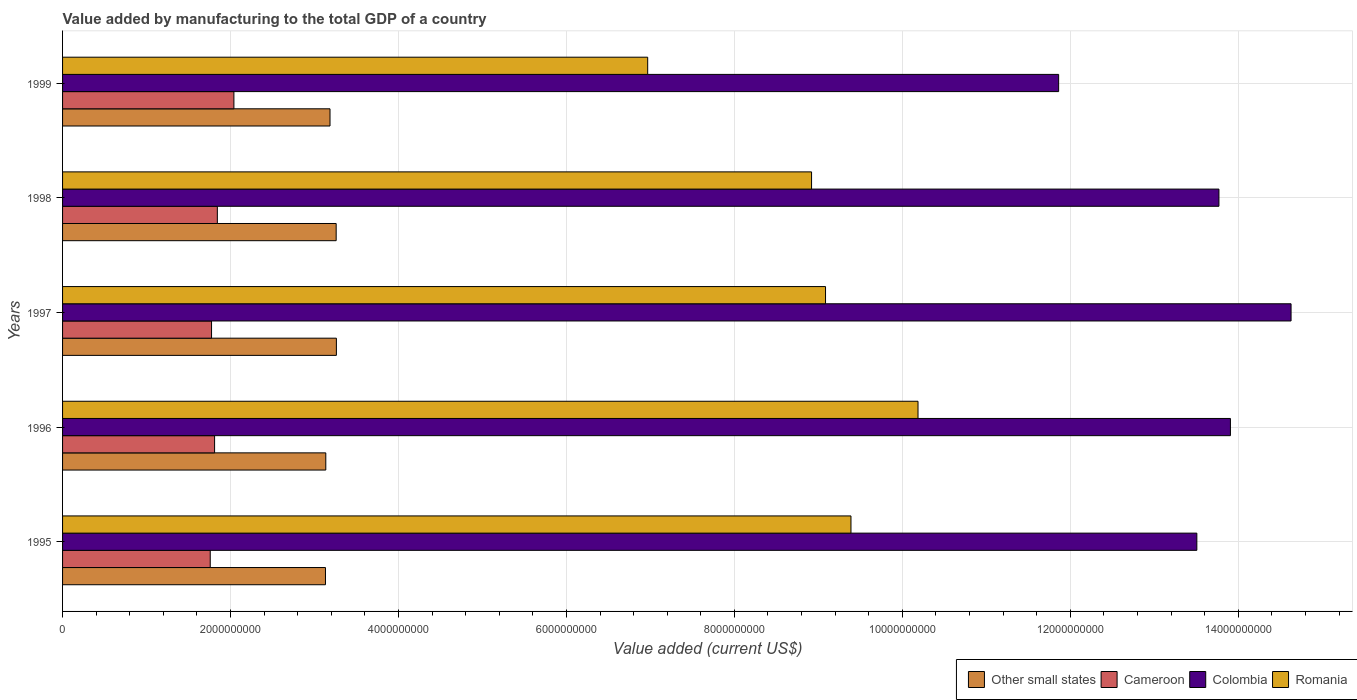How many groups of bars are there?
Your answer should be very brief. 5. How many bars are there on the 2nd tick from the bottom?
Your answer should be very brief. 4. What is the label of the 4th group of bars from the top?
Give a very brief answer. 1996. In how many cases, is the number of bars for a given year not equal to the number of legend labels?
Your response must be concise. 0. What is the value added by manufacturing to the total GDP in Romania in 1996?
Provide a short and direct response. 1.02e+1. Across all years, what is the maximum value added by manufacturing to the total GDP in Romania?
Provide a succinct answer. 1.02e+1. Across all years, what is the minimum value added by manufacturing to the total GDP in Colombia?
Provide a succinct answer. 1.19e+1. In which year was the value added by manufacturing to the total GDP in Colombia maximum?
Your answer should be compact. 1997. What is the total value added by manufacturing to the total GDP in Colombia in the graph?
Give a very brief answer. 6.77e+1. What is the difference between the value added by manufacturing to the total GDP in Other small states in 1995 and that in 1999?
Provide a succinct answer. -5.41e+07. What is the difference between the value added by manufacturing to the total GDP in Cameroon in 1996 and the value added by manufacturing to the total GDP in Other small states in 1995?
Your answer should be very brief. -1.32e+09. What is the average value added by manufacturing to the total GDP in Cameroon per year?
Make the answer very short. 1.85e+09. In the year 1996, what is the difference between the value added by manufacturing to the total GDP in Cameroon and value added by manufacturing to the total GDP in Colombia?
Your answer should be very brief. -1.21e+1. What is the ratio of the value added by manufacturing to the total GDP in Other small states in 1995 to that in 1999?
Keep it short and to the point. 0.98. Is the value added by manufacturing to the total GDP in Colombia in 1995 less than that in 1997?
Your answer should be very brief. Yes. What is the difference between the highest and the second highest value added by manufacturing to the total GDP in Cameroon?
Offer a terse response. 1.97e+08. What is the difference between the highest and the lowest value added by manufacturing to the total GDP in Cameroon?
Offer a terse response. 2.82e+08. In how many years, is the value added by manufacturing to the total GDP in Other small states greater than the average value added by manufacturing to the total GDP in Other small states taken over all years?
Offer a terse response. 2. Is it the case that in every year, the sum of the value added by manufacturing to the total GDP in Colombia and value added by manufacturing to the total GDP in Cameroon is greater than the sum of value added by manufacturing to the total GDP in Other small states and value added by manufacturing to the total GDP in Romania?
Your answer should be very brief. No. What does the 3rd bar from the top in 1999 represents?
Keep it short and to the point. Cameroon. What does the 4th bar from the bottom in 1996 represents?
Offer a very short reply. Romania. Is it the case that in every year, the sum of the value added by manufacturing to the total GDP in Cameroon and value added by manufacturing to the total GDP in Other small states is greater than the value added by manufacturing to the total GDP in Colombia?
Offer a terse response. No. How many bars are there?
Your answer should be very brief. 20. How many years are there in the graph?
Give a very brief answer. 5. What is the difference between two consecutive major ticks on the X-axis?
Make the answer very short. 2.00e+09. Are the values on the major ticks of X-axis written in scientific E-notation?
Ensure brevity in your answer.  No. Where does the legend appear in the graph?
Ensure brevity in your answer.  Bottom right. How many legend labels are there?
Your answer should be compact. 4. What is the title of the graph?
Your answer should be compact. Value added by manufacturing to the total GDP of a country. Does "St. Kitts and Nevis" appear as one of the legend labels in the graph?
Offer a very short reply. No. What is the label or title of the X-axis?
Keep it short and to the point. Value added (current US$). What is the Value added (current US$) of Other small states in 1995?
Make the answer very short. 3.13e+09. What is the Value added (current US$) of Cameroon in 1995?
Your response must be concise. 1.76e+09. What is the Value added (current US$) in Colombia in 1995?
Ensure brevity in your answer.  1.35e+1. What is the Value added (current US$) in Romania in 1995?
Your answer should be compact. 9.39e+09. What is the Value added (current US$) of Other small states in 1996?
Your response must be concise. 3.13e+09. What is the Value added (current US$) in Cameroon in 1996?
Give a very brief answer. 1.81e+09. What is the Value added (current US$) of Colombia in 1996?
Your answer should be compact. 1.39e+1. What is the Value added (current US$) in Romania in 1996?
Offer a terse response. 1.02e+1. What is the Value added (current US$) in Other small states in 1997?
Keep it short and to the point. 3.26e+09. What is the Value added (current US$) of Cameroon in 1997?
Offer a very short reply. 1.77e+09. What is the Value added (current US$) of Colombia in 1997?
Your answer should be very brief. 1.46e+1. What is the Value added (current US$) in Romania in 1997?
Provide a succinct answer. 9.09e+09. What is the Value added (current US$) of Other small states in 1998?
Give a very brief answer. 3.26e+09. What is the Value added (current US$) in Cameroon in 1998?
Ensure brevity in your answer.  1.84e+09. What is the Value added (current US$) of Colombia in 1998?
Give a very brief answer. 1.38e+1. What is the Value added (current US$) in Romania in 1998?
Offer a very short reply. 8.92e+09. What is the Value added (current US$) of Other small states in 1999?
Provide a succinct answer. 3.18e+09. What is the Value added (current US$) in Cameroon in 1999?
Ensure brevity in your answer.  2.04e+09. What is the Value added (current US$) of Colombia in 1999?
Provide a short and direct response. 1.19e+1. What is the Value added (current US$) in Romania in 1999?
Your response must be concise. 6.97e+09. Across all years, what is the maximum Value added (current US$) in Other small states?
Provide a short and direct response. 3.26e+09. Across all years, what is the maximum Value added (current US$) in Cameroon?
Keep it short and to the point. 2.04e+09. Across all years, what is the maximum Value added (current US$) of Colombia?
Make the answer very short. 1.46e+1. Across all years, what is the maximum Value added (current US$) of Romania?
Give a very brief answer. 1.02e+1. Across all years, what is the minimum Value added (current US$) in Other small states?
Give a very brief answer. 3.13e+09. Across all years, what is the minimum Value added (current US$) of Cameroon?
Offer a very short reply. 1.76e+09. Across all years, what is the minimum Value added (current US$) in Colombia?
Your answer should be compact. 1.19e+1. Across all years, what is the minimum Value added (current US$) of Romania?
Offer a terse response. 6.97e+09. What is the total Value added (current US$) in Other small states in the graph?
Offer a very short reply. 1.60e+1. What is the total Value added (current US$) in Cameroon in the graph?
Give a very brief answer. 9.23e+09. What is the total Value added (current US$) of Colombia in the graph?
Give a very brief answer. 6.77e+1. What is the total Value added (current US$) in Romania in the graph?
Ensure brevity in your answer.  4.45e+1. What is the difference between the Value added (current US$) of Other small states in 1995 and that in 1996?
Keep it short and to the point. -3.87e+06. What is the difference between the Value added (current US$) of Cameroon in 1995 and that in 1996?
Offer a terse response. -5.19e+07. What is the difference between the Value added (current US$) of Colombia in 1995 and that in 1996?
Your answer should be compact. -4.00e+08. What is the difference between the Value added (current US$) of Romania in 1995 and that in 1996?
Offer a terse response. -7.98e+08. What is the difference between the Value added (current US$) in Other small states in 1995 and that in 1997?
Offer a very short reply. -1.30e+08. What is the difference between the Value added (current US$) in Cameroon in 1995 and that in 1997?
Keep it short and to the point. -1.56e+07. What is the difference between the Value added (current US$) in Colombia in 1995 and that in 1997?
Ensure brevity in your answer.  -1.12e+09. What is the difference between the Value added (current US$) of Romania in 1995 and that in 1997?
Make the answer very short. 3.03e+08. What is the difference between the Value added (current US$) of Other small states in 1995 and that in 1998?
Offer a terse response. -1.27e+08. What is the difference between the Value added (current US$) of Cameroon in 1995 and that in 1998?
Your answer should be very brief. -8.46e+07. What is the difference between the Value added (current US$) in Colombia in 1995 and that in 1998?
Make the answer very short. -2.63e+08. What is the difference between the Value added (current US$) of Romania in 1995 and that in 1998?
Give a very brief answer. 4.69e+08. What is the difference between the Value added (current US$) in Other small states in 1995 and that in 1999?
Offer a very short reply. -5.41e+07. What is the difference between the Value added (current US$) in Cameroon in 1995 and that in 1999?
Offer a terse response. -2.82e+08. What is the difference between the Value added (current US$) in Colombia in 1995 and that in 1999?
Give a very brief answer. 1.65e+09. What is the difference between the Value added (current US$) of Romania in 1995 and that in 1999?
Provide a short and direct response. 2.42e+09. What is the difference between the Value added (current US$) of Other small states in 1996 and that in 1997?
Keep it short and to the point. -1.26e+08. What is the difference between the Value added (current US$) in Cameroon in 1996 and that in 1997?
Keep it short and to the point. 3.63e+07. What is the difference between the Value added (current US$) of Colombia in 1996 and that in 1997?
Offer a terse response. -7.22e+08. What is the difference between the Value added (current US$) in Romania in 1996 and that in 1997?
Keep it short and to the point. 1.10e+09. What is the difference between the Value added (current US$) of Other small states in 1996 and that in 1998?
Your response must be concise. -1.24e+08. What is the difference between the Value added (current US$) of Cameroon in 1996 and that in 1998?
Keep it short and to the point. -3.27e+07. What is the difference between the Value added (current US$) in Colombia in 1996 and that in 1998?
Make the answer very short. 1.37e+08. What is the difference between the Value added (current US$) in Romania in 1996 and that in 1998?
Make the answer very short. 1.27e+09. What is the difference between the Value added (current US$) of Other small states in 1996 and that in 1999?
Provide a short and direct response. -5.02e+07. What is the difference between the Value added (current US$) in Cameroon in 1996 and that in 1999?
Your answer should be very brief. -2.30e+08. What is the difference between the Value added (current US$) in Colombia in 1996 and that in 1999?
Your answer should be compact. 2.05e+09. What is the difference between the Value added (current US$) in Romania in 1996 and that in 1999?
Your answer should be very brief. 3.22e+09. What is the difference between the Value added (current US$) of Other small states in 1997 and that in 1998?
Make the answer very short. 2.66e+06. What is the difference between the Value added (current US$) of Cameroon in 1997 and that in 1998?
Offer a terse response. -6.90e+07. What is the difference between the Value added (current US$) of Colombia in 1997 and that in 1998?
Give a very brief answer. 8.59e+08. What is the difference between the Value added (current US$) of Romania in 1997 and that in 1998?
Keep it short and to the point. 1.66e+08. What is the difference between the Value added (current US$) of Other small states in 1997 and that in 1999?
Make the answer very short. 7.60e+07. What is the difference between the Value added (current US$) in Cameroon in 1997 and that in 1999?
Give a very brief answer. -2.66e+08. What is the difference between the Value added (current US$) in Colombia in 1997 and that in 1999?
Make the answer very short. 2.77e+09. What is the difference between the Value added (current US$) in Romania in 1997 and that in 1999?
Your answer should be very brief. 2.12e+09. What is the difference between the Value added (current US$) in Other small states in 1998 and that in 1999?
Offer a terse response. 7.34e+07. What is the difference between the Value added (current US$) of Cameroon in 1998 and that in 1999?
Keep it short and to the point. -1.97e+08. What is the difference between the Value added (current US$) in Colombia in 1998 and that in 1999?
Provide a succinct answer. 1.91e+09. What is the difference between the Value added (current US$) in Romania in 1998 and that in 1999?
Provide a succinct answer. 1.95e+09. What is the difference between the Value added (current US$) in Other small states in 1995 and the Value added (current US$) in Cameroon in 1996?
Offer a very short reply. 1.32e+09. What is the difference between the Value added (current US$) in Other small states in 1995 and the Value added (current US$) in Colombia in 1996?
Ensure brevity in your answer.  -1.08e+1. What is the difference between the Value added (current US$) in Other small states in 1995 and the Value added (current US$) in Romania in 1996?
Your response must be concise. -7.06e+09. What is the difference between the Value added (current US$) in Cameroon in 1995 and the Value added (current US$) in Colombia in 1996?
Your response must be concise. -1.21e+1. What is the difference between the Value added (current US$) of Cameroon in 1995 and the Value added (current US$) of Romania in 1996?
Your response must be concise. -8.43e+09. What is the difference between the Value added (current US$) in Colombia in 1995 and the Value added (current US$) in Romania in 1996?
Give a very brief answer. 3.32e+09. What is the difference between the Value added (current US$) of Other small states in 1995 and the Value added (current US$) of Cameroon in 1997?
Your answer should be very brief. 1.36e+09. What is the difference between the Value added (current US$) of Other small states in 1995 and the Value added (current US$) of Colombia in 1997?
Provide a short and direct response. -1.15e+1. What is the difference between the Value added (current US$) in Other small states in 1995 and the Value added (current US$) in Romania in 1997?
Make the answer very short. -5.95e+09. What is the difference between the Value added (current US$) of Cameroon in 1995 and the Value added (current US$) of Colombia in 1997?
Make the answer very short. -1.29e+1. What is the difference between the Value added (current US$) of Cameroon in 1995 and the Value added (current US$) of Romania in 1997?
Keep it short and to the point. -7.33e+09. What is the difference between the Value added (current US$) of Colombia in 1995 and the Value added (current US$) of Romania in 1997?
Your answer should be very brief. 4.42e+09. What is the difference between the Value added (current US$) of Other small states in 1995 and the Value added (current US$) of Cameroon in 1998?
Your answer should be very brief. 1.29e+09. What is the difference between the Value added (current US$) in Other small states in 1995 and the Value added (current US$) in Colombia in 1998?
Provide a short and direct response. -1.06e+1. What is the difference between the Value added (current US$) in Other small states in 1995 and the Value added (current US$) in Romania in 1998?
Offer a terse response. -5.79e+09. What is the difference between the Value added (current US$) in Cameroon in 1995 and the Value added (current US$) in Colombia in 1998?
Ensure brevity in your answer.  -1.20e+1. What is the difference between the Value added (current US$) in Cameroon in 1995 and the Value added (current US$) in Romania in 1998?
Provide a succinct answer. -7.16e+09. What is the difference between the Value added (current US$) in Colombia in 1995 and the Value added (current US$) in Romania in 1998?
Your response must be concise. 4.59e+09. What is the difference between the Value added (current US$) of Other small states in 1995 and the Value added (current US$) of Cameroon in 1999?
Give a very brief answer. 1.09e+09. What is the difference between the Value added (current US$) of Other small states in 1995 and the Value added (current US$) of Colombia in 1999?
Your answer should be compact. -8.73e+09. What is the difference between the Value added (current US$) in Other small states in 1995 and the Value added (current US$) in Romania in 1999?
Your answer should be very brief. -3.84e+09. What is the difference between the Value added (current US$) in Cameroon in 1995 and the Value added (current US$) in Colombia in 1999?
Offer a very short reply. -1.01e+1. What is the difference between the Value added (current US$) of Cameroon in 1995 and the Value added (current US$) of Romania in 1999?
Your response must be concise. -5.21e+09. What is the difference between the Value added (current US$) in Colombia in 1995 and the Value added (current US$) in Romania in 1999?
Provide a succinct answer. 6.54e+09. What is the difference between the Value added (current US$) of Other small states in 1996 and the Value added (current US$) of Cameroon in 1997?
Your answer should be very brief. 1.36e+09. What is the difference between the Value added (current US$) of Other small states in 1996 and the Value added (current US$) of Colombia in 1997?
Make the answer very short. -1.15e+1. What is the difference between the Value added (current US$) of Other small states in 1996 and the Value added (current US$) of Romania in 1997?
Provide a short and direct response. -5.95e+09. What is the difference between the Value added (current US$) of Cameroon in 1996 and the Value added (current US$) of Colombia in 1997?
Ensure brevity in your answer.  -1.28e+1. What is the difference between the Value added (current US$) of Cameroon in 1996 and the Value added (current US$) of Romania in 1997?
Provide a short and direct response. -7.27e+09. What is the difference between the Value added (current US$) of Colombia in 1996 and the Value added (current US$) of Romania in 1997?
Make the answer very short. 4.82e+09. What is the difference between the Value added (current US$) in Other small states in 1996 and the Value added (current US$) in Cameroon in 1998?
Keep it short and to the point. 1.29e+09. What is the difference between the Value added (current US$) of Other small states in 1996 and the Value added (current US$) of Colombia in 1998?
Keep it short and to the point. -1.06e+1. What is the difference between the Value added (current US$) of Other small states in 1996 and the Value added (current US$) of Romania in 1998?
Keep it short and to the point. -5.78e+09. What is the difference between the Value added (current US$) in Cameroon in 1996 and the Value added (current US$) in Colombia in 1998?
Your answer should be compact. -1.20e+1. What is the difference between the Value added (current US$) in Cameroon in 1996 and the Value added (current US$) in Romania in 1998?
Offer a very short reply. -7.11e+09. What is the difference between the Value added (current US$) in Colombia in 1996 and the Value added (current US$) in Romania in 1998?
Make the answer very short. 4.99e+09. What is the difference between the Value added (current US$) of Other small states in 1996 and the Value added (current US$) of Cameroon in 1999?
Keep it short and to the point. 1.09e+09. What is the difference between the Value added (current US$) in Other small states in 1996 and the Value added (current US$) in Colombia in 1999?
Your response must be concise. -8.73e+09. What is the difference between the Value added (current US$) in Other small states in 1996 and the Value added (current US$) in Romania in 1999?
Make the answer very short. -3.83e+09. What is the difference between the Value added (current US$) of Cameroon in 1996 and the Value added (current US$) of Colombia in 1999?
Provide a short and direct response. -1.01e+1. What is the difference between the Value added (current US$) of Cameroon in 1996 and the Value added (current US$) of Romania in 1999?
Provide a succinct answer. -5.16e+09. What is the difference between the Value added (current US$) of Colombia in 1996 and the Value added (current US$) of Romania in 1999?
Your response must be concise. 6.94e+09. What is the difference between the Value added (current US$) of Other small states in 1997 and the Value added (current US$) of Cameroon in 1998?
Offer a very short reply. 1.42e+09. What is the difference between the Value added (current US$) in Other small states in 1997 and the Value added (current US$) in Colombia in 1998?
Make the answer very short. -1.05e+1. What is the difference between the Value added (current US$) in Other small states in 1997 and the Value added (current US$) in Romania in 1998?
Your answer should be compact. -5.66e+09. What is the difference between the Value added (current US$) in Cameroon in 1997 and the Value added (current US$) in Colombia in 1998?
Provide a succinct answer. -1.20e+1. What is the difference between the Value added (current US$) of Cameroon in 1997 and the Value added (current US$) of Romania in 1998?
Provide a succinct answer. -7.14e+09. What is the difference between the Value added (current US$) in Colombia in 1997 and the Value added (current US$) in Romania in 1998?
Keep it short and to the point. 5.71e+09. What is the difference between the Value added (current US$) in Other small states in 1997 and the Value added (current US$) in Cameroon in 1999?
Your answer should be very brief. 1.22e+09. What is the difference between the Value added (current US$) in Other small states in 1997 and the Value added (current US$) in Colombia in 1999?
Offer a terse response. -8.60e+09. What is the difference between the Value added (current US$) of Other small states in 1997 and the Value added (current US$) of Romania in 1999?
Provide a short and direct response. -3.71e+09. What is the difference between the Value added (current US$) of Cameroon in 1997 and the Value added (current US$) of Colombia in 1999?
Your response must be concise. -1.01e+1. What is the difference between the Value added (current US$) of Cameroon in 1997 and the Value added (current US$) of Romania in 1999?
Make the answer very short. -5.19e+09. What is the difference between the Value added (current US$) of Colombia in 1997 and the Value added (current US$) of Romania in 1999?
Ensure brevity in your answer.  7.66e+09. What is the difference between the Value added (current US$) of Other small states in 1998 and the Value added (current US$) of Cameroon in 1999?
Your answer should be very brief. 1.22e+09. What is the difference between the Value added (current US$) of Other small states in 1998 and the Value added (current US$) of Colombia in 1999?
Your answer should be very brief. -8.60e+09. What is the difference between the Value added (current US$) in Other small states in 1998 and the Value added (current US$) in Romania in 1999?
Provide a succinct answer. -3.71e+09. What is the difference between the Value added (current US$) of Cameroon in 1998 and the Value added (current US$) of Colombia in 1999?
Keep it short and to the point. -1.00e+1. What is the difference between the Value added (current US$) in Cameroon in 1998 and the Value added (current US$) in Romania in 1999?
Your response must be concise. -5.12e+09. What is the difference between the Value added (current US$) in Colombia in 1998 and the Value added (current US$) in Romania in 1999?
Provide a succinct answer. 6.80e+09. What is the average Value added (current US$) in Other small states per year?
Ensure brevity in your answer.  3.19e+09. What is the average Value added (current US$) of Cameroon per year?
Your response must be concise. 1.85e+09. What is the average Value added (current US$) of Colombia per year?
Make the answer very short. 1.35e+1. What is the average Value added (current US$) of Romania per year?
Provide a short and direct response. 8.91e+09. In the year 1995, what is the difference between the Value added (current US$) of Other small states and Value added (current US$) of Cameroon?
Make the answer very short. 1.37e+09. In the year 1995, what is the difference between the Value added (current US$) in Other small states and Value added (current US$) in Colombia?
Offer a very short reply. -1.04e+1. In the year 1995, what is the difference between the Value added (current US$) in Other small states and Value added (current US$) in Romania?
Your answer should be very brief. -6.26e+09. In the year 1995, what is the difference between the Value added (current US$) in Cameroon and Value added (current US$) in Colombia?
Keep it short and to the point. -1.17e+1. In the year 1995, what is the difference between the Value added (current US$) in Cameroon and Value added (current US$) in Romania?
Offer a terse response. -7.63e+09. In the year 1995, what is the difference between the Value added (current US$) of Colombia and Value added (current US$) of Romania?
Give a very brief answer. 4.12e+09. In the year 1996, what is the difference between the Value added (current US$) in Other small states and Value added (current US$) in Cameroon?
Give a very brief answer. 1.32e+09. In the year 1996, what is the difference between the Value added (current US$) of Other small states and Value added (current US$) of Colombia?
Give a very brief answer. -1.08e+1. In the year 1996, what is the difference between the Value added (current US$) of Other small states and Value added (current US$) of Romania?
Ensure brevity in your answer.  -7.05e+09. In the year 1996, what is the difference between the Value added (current US$) of Cameroon and Value added (current US$) of Colombia?
Your answer should be very brief. -1.21e+1. In the year 1996, what is the difference between the Value added (current US$) of Cameroon and Value added (current US$) of Romania?
Offer a very short reply. -8.38e+09. In the year 1996, what is the difference between the Value added (current US$) of Colombia and Value added (current US$) of Romania?
Keep it short and to the point. 3.72e+09. In the year 1997, what is the difference between the Value added (current US$) in Other small states and Value added (current US$) in Cameroon?
Provide a succinct answer. 1.49e+09. In the year 1997, what is the difference between the Value added (current US$) in Other small states and Value added (current US$) in Colombia?
Make the answer very short. -1.14e+1. In the year 1997, what is the difference between the Value added (current US$) in Other small states and Value added (current US$) in Romania?
Provide a short and direct response. -5.82e+09. In the year 1997, what is the difference between the Value added (current US$) in Cameroon and Value added (current US$) in Colombia?
Offer a terse response. -1.29e+1. In the year 1997, what is the difference between the Value added (current US$) in Cameroon and Value added (current US$) in Romania?
Your response must be concise. -7.31e+09. In the year 1997, what is the difference between the Value added (current US$) of Colombia and Value added (current US$) of Romania?
Offer a very short reply. 5.54e+09. In the year 1998, what is the difference between the Value added (current US$) of Other small states and Value added (current US$) of Cameroon?
Keep it short and to the point. 1.42e+09. In the year 1998, what is the difference between the Value added (current US$) in Other small states and Value added (current US$) in Colombia?
Provide a short and direct response. -1.05e+1. In the year 1998, what is the difference between the Value added (current US$) of Other small states and Value added (current US$) of Romania?
Provide a short and direct response. -5.66e+09. In the year 1998, what is the difference between the Value added (current US$) in Cameroon and Value added (current US$) in Colombia?
Your response must be concise. -1.19e+1. In the year 1998, what is the difference between the Value added (current US$) in Cameroon and Value added (current US$) in Romania?
Your answer should be compact. -7.08e+09. In the year 1998, what is the difference between the Value added (current US$) of Colombia and Value added (current US$) of Romania?
Your answer should be compact. 4.85e+09. In the year 1999, what is the difference between the Value added (current US$) in Other small states and Value added (current US$) in Cameroon?
Provide a succinct answer. 1.14e+09. In the year 1999, what is the difference between the Value added (current US$) in Other small states and Value added (current US$) in Colombia?
Your answer should be very brief. -8.68e+09. In the year 1999, what is the difference between the Value added (current US$) of Other small states and Value added (current US$) of Romania?
Keep it short and to the point. -3.78e+09. In the year 1999, what is the difference between the Value added (current US$) of Cameroon and Value added (current US$) of Colombia?
Give a very brief answer. -9.82e+09. In the year 1999, what is the difference between the Value added (current US$) in Cameroon and Value added (current US$) in Romania?
Your answer should be compact. -4.93e+09. In the year 1999, what is the difference between the Value added (current US$) in Colombia and Value added (current US$) in Romania?
Provide a short and direct response. 4.89e+09. What is the ratio of the Value added (current US$) in Cameroon in 1995 to that in 1996?
Give a very brief answer. 0.97. What is the ratio of the Value added (current US$) in Colombia in 1995 to that in 1996?
Your answer should be very brief. 0.97. What is the ratio of the Value added (current US$) of Romania in 1995 to that in 1996?
Give a very brief answer. 0.92. What is the ratio of the Value added (current US$) of Other small states in 1995 to that in 1997?
Your answer should be compact. 0.96. What is the ratio of the Value added (current US$) in Colombia in 1995 to that in 1997?
Offer a terse response. 0.92. What is the ratio of the Value added (current US$) of Romania in 1995 to that in 1997?
Offer a terse response. 1.03. What is the ratio of the Value added (current US$) of Other small states in 1995 to that in 1998?
Keep it short and to the point. 0.96. What is the ratio of the Value added (current US$) of Cameroon in 1995 to that in 1998?
Ensure brevity in your answer.  0.95. What is the ratio of the Value added (current US$) in Colombia in 1995 to that in 1998?
Provide a short and direct response. 0.98. What is the ratio of the Value added (current US$) in Romania in 1995 to that in 1998?
Offer a terse response. 1.05. What is the ratio of the Value added (current US$) in Other small states in 1995 to that in 1999?
Your answer should be very brief. 0.98. What is the ratio of the Value added (current US$) of Cameroon in 1995 to that in 1999?
Make the answer very short. 0.86. What is the ratio of the Value added (current US$) in Colombia in 1995 to that in 1999?
Provide a short and direct response. 1.14. What is the ratio of the Value added (current US$) in Romania in 1995 to that in 1999?
Your answer should be compact. 1.35. What is the ratio of the Value added (current US$) in Other small states in 1996 to that in 1997?
Give a very brief answer. 0.96. What is the ratio of the Value added (current US$) of Cameroon in 1996 to that in 1997?
Keep it short and to the point. 1.02. What is the ratio of the Value added (current US$) of Colombia in 1996 to that in 1997?
Offer a very short reply. 0.95. What is the ratio of the Value added (current US$) of Romania in 1996 to that in 1997?
Ensure brevity in your answer.  1.12. What is the ratio of the Value added (current US$) in Other small states in 1996 to that in 1998?
Your answer should be very brief. 0.96. What is the ratio of the Value added (current US$) in Cameroon in 1996 to that in 1998?
Your answer should be compact. 0.98. What is the ratio of the Value added (current US$) in Colombia in 1996 to that in 1998?
Keep it short and to the point. 1.01. What is the ratio of the Value added (current US$) in Romania in 1996 to that in 1998?
Provide a short and direct response. 1.14. What is the ratio of the Value added (current US$) in Other small states in 1996 to that in 1999?
Ensure brevity in your answer.  0.98. What is the ratio of the Value added (current US$) of Cameroon in 1996 to that in 1999?
Keep it short and to the point. 0.89. What is the ratio of the Value added (current US$) in Colombia in 1996 to that in 1999?
Give a very brief answer. 1.17. What is the ratio of the Value added (current US$) of Romania in 1996 to that in 1999?
Your answer should be compact. 1.46. What is the ratio of the Value added (current US$) in Cameroon in 1997 to that in 1998?
Your response must be concise. 0.96. What is the ratio of the Value added (current US$) in Colombia in 1997 to that in 1998?
Make the answer very short. 1.06. What is the ratio of the Value added (current US$) in Romania in 1997 to that in 1998?
Offer a terse response. 1.02. What is the ratio of the Value added (current US$) in Other small states in 1997 to that in 1999?
Ensure brevity in your answer.  1.02. What is the ratio of the Value added (current US$) of Cameroon in 1997 to that in 1999?
Your answer should be very brief. 0.87. What is the ratio of the Value added (current US$) in Colombia in 1997 to that in 1999?
Your answer should be very brief. 1.23. What is the ratio of the Value added (current US$) of Romania in 1997 to that in 1999?
Make the answer very short. 1.3. What is the ratio of the Value added (current US$) in Other small states in 1998 to that in 1999?
Keep it short and to the point. 1.02. What is the ratio of the Value added (current US$) in Cameroon in 1998 to that in 1999?
Offer a very short reply. 0.9. What is the ratio of the Value added (current US$) of Colombia in 1998 to that in 1999?
Your response must be concise. 1.16. What is the ratio of the Value added (current US$) in Romania in 1998 to that in 1999?
Give a very brief answer. 1.28. What is the difference between the highest and the second highest Value added (current US$) in Other small states?
Your answer should be compact. 2.66e+06. What is the difference between the highest and the second highest Value added (current US$) of Cameroon?
Your response must be concise. 1.97e+08. What is the difference between the highest and the second highest Value added (current US$) of Colombia?
Your response must be concise. 7.22e+08. What is the difference between the highest and the second highest Value added (current US$) of Romania?
Make the answer very short. 7.98e+08. What is the difference between the highest and the lowest Value added (current US$) in Other small states?
Provide a succinct answer. 1.30e+08. What is the difference between the highest and the lowest Value added (current US$) of Cameroon?
Offer a terse response. 2.82e+08. What is the difference between the highest and the lowest Value added (current US$) of Colombia?
Provide a succinct answer. 2.77e+09. What is the difference between the highest and the lowest Value added (current US$) in Romania?
Provide a short and direct response. 3.22e+09. 